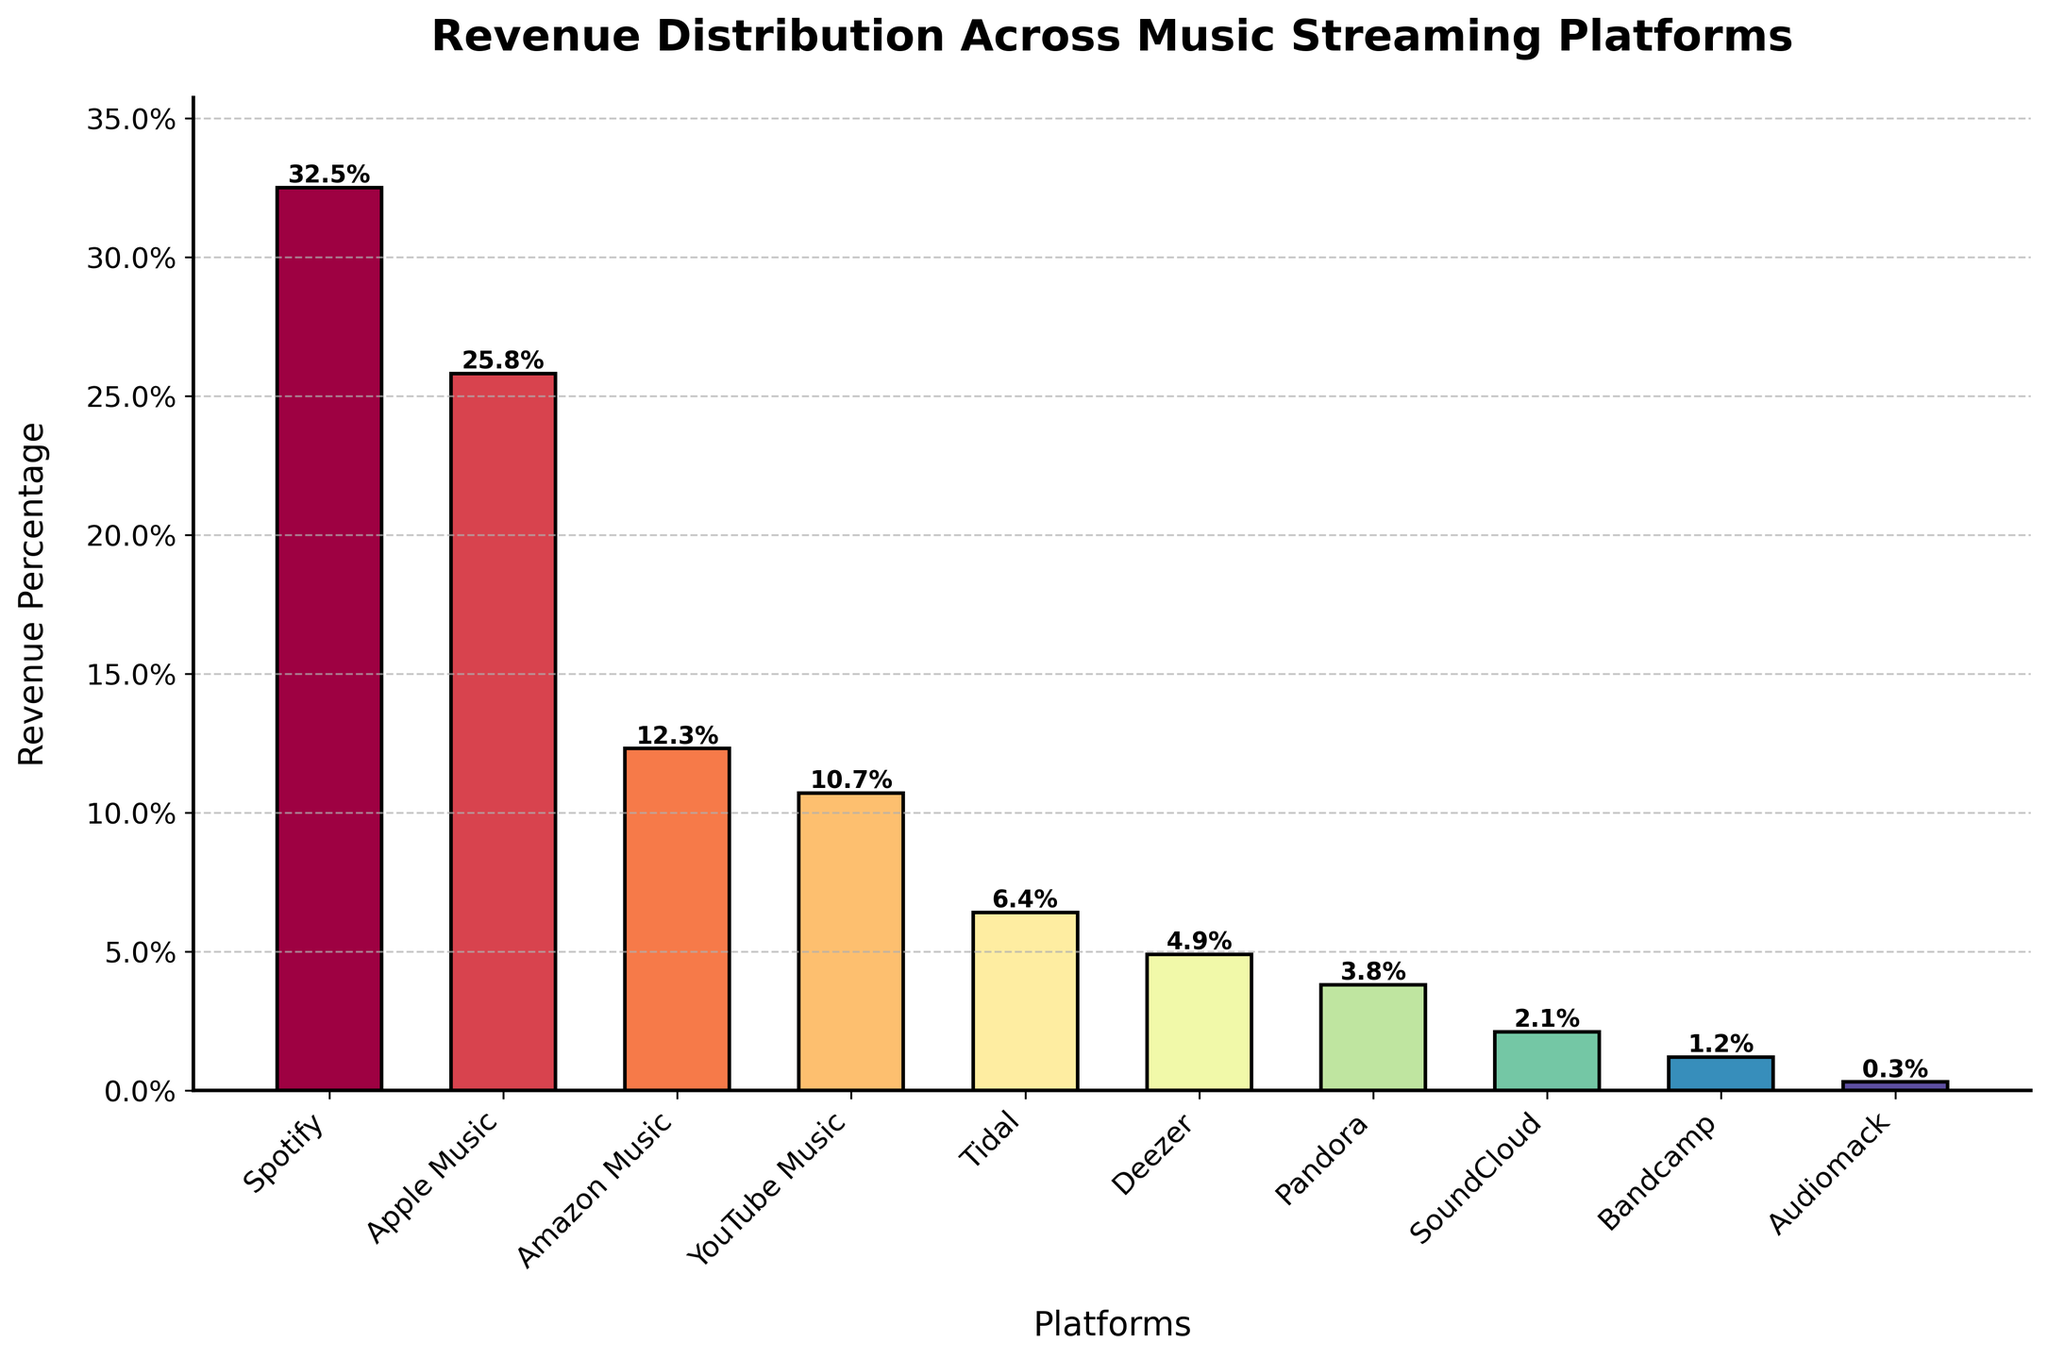Which platform has the highest revenue percentage? By observing the heights of the bars, Spotify has the tallest bar, indicating the highest revenue percentage.
Answer: Spotify Which platform has the lowest revenue percentage? By observing the heights of the bars, Audiomack has the shortest bar, indicating the lowest revenue percentage.
Answer: Audiomack How much higher is Spotify's revenue percentage compared to Apple Music's? Spotify has a revenue percentage of 32.5%, and Apple Music has 25.8%. The difference is 32.5% - 25.8% = 6.7%.
Answer: 6.7% What's the total revenue percentage for Amazon Music and YouTube Music combined? Amazon Music has a revenue percentage of 12.3%, and YouTube Music has 10.7%. Combined, it's 12.3% + 10.7% = 23%.
Answer: 23% Is Apple Music's revenue percentage greater than twice SoundCloud's revenue percentage? Apple Music's revenue percentage is 25.8%, and twice SoundCloud's revenue percentage is 2.1% * 2 = 4.2%. Since 25.8% > 4.2%, the answer is yes.
Answer: Yes What is the average revenue percentage of Tidal, Deezer, and Pandora? Sum the revenue percentages of Tidal (6.4%), Deezer (4.9%), and Pandora (3.8%): 6.4% + 4.9% + 3.8% = 15.1%. Divide by 3 to find the average: 15.1% / 3 = 5.03%.
Answer: 5.03% Which has a higher revenue percentage: Amazon Music or the combined percentages of Pandora and SoundCloud? Amazon Music has a revenue percentage of 12.3%. Pandora and SoundCloud combined are 3.8% + 2.1% = 5.9%. Since 12.3% > 5.9%, Amazon Music has a higher revenue percentage.
Answer: Amazon Music What is the difference in revenue percentage between Deezer and Tidal? Deezer has a 4.9% revenue percentage, and Tidal has 6.4%. The difference is 6.4% - 4.9% = 1.5%.
Answer: 1.5% Which platform's bar color appears closest to red? By observing the spectral color gradient, Spotify, being the first bar in the spectrum, appears closest to red.
Answer: Spotify 